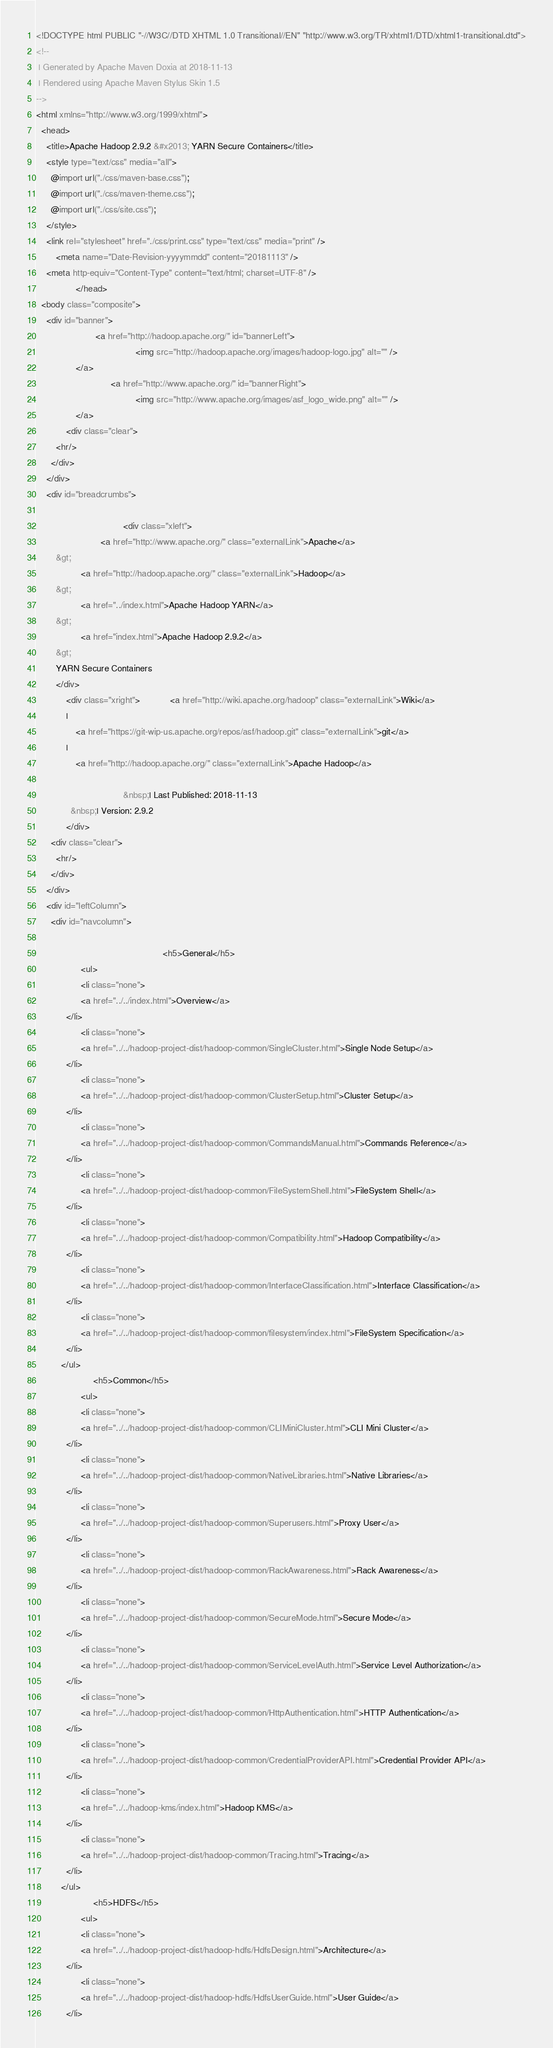Convert code to text. <code><loc_0><loc_0><loc_500><loc_500><_HTML_><!DOCTYPE html PUBLIC "-//W3C//DTD XHTML 1.0 Transitional//EN" "http://www.w3.org/TR/xhtml1/DTD/xhtml1-transitional.dtd">
<!--
 | Generated by Apache Maven Doxia at 2018-11-13
 | Rendered using Apache Maven Stylus Skin 1.5
-->
<html xmlns="http://www.w3.org/1999/xhtml">
  <head>
    <title>Apache Hadoop 2.9.2 &#x2013; YARN Secure Containers</title>
    <style type="text/css" media="all">
      @import url("./css/maven-base.css");
      @import url("./css/maven-theme.css");
      @import url("./css/site.css");
    </style>
    <link rel="stylesheet" href="./css/print.css" type="text/css" media="print" />
        <meta name="Date-Revision-yyyymmdd" content="20181113" />
    <meta http-equiv="Content-Type" content="text/html; charset=UTF-8" />
                </head>
  <body class="composite">
    <div id="banner">
                        <a href="http://hadoop.apache.org/" id="bannerLeft">
                                        <img src="http://hadoop.apache.org/images/hadoop-logo.jpg" alt="" />
                </a>
                              <a href="http://www.apache.org/" id="bannerRight">
                                        <img src="http://www.apache.org/images/asf_logo_wide.png" alt="" />
                </a>
            <div class="clear">
        <hr/>
      </div>
    </div>
    <div id="breadcrumbs">
            
                                   <div class="xleft">
                          <a href="http://www.apache.org/" class="externalLink">Apache</a>
        &gt;
                  <a href="http://hadoop.apache.org/" class="externalLink">Hadoop</a>
        &gt;
                  <a href="../index.html">Apache Hadoop YARN</a>
        &gt;
                  <a href="index.html">Apache Hadoop 2.9.2</a>
        &gt;
        YARN Secure Containers
        </div>
            <div class="xright">            <a href="http://wiki.apache.org/hadoop" class="externalLink">Wiki</a>
            |
                <a href="https://git-wip-us.apache.org/repos/asf/hadoop.git" class="externalLink">git</a>
            |
                <a href="http://hadoop.apache.org/" class="externalLink">Apache Hadoop</a>
              
                                   &nbsp;| Last Published: 2018-11-13
              &nbsp;| Version: 2.9.2
            </div>
      <div class="clear">
        <hr/>
      </div>
    </div>
    <div id="leftColumn">
      <div id="navcolumn">
             
                                                   <h5>General</h5>
                  <ul>
                  <li class="none">
                  <a href="../../index.html">Overview</a>
            </li>
                  <li class="none">
                  <a href="../../hadoop-project-dist/hadoop-common/SingleCluster.html">Single Node Setup</a>
            </li>
                  <li class="none">
                  <a href="../../hadoop-project-dist/hadoop-common/ClusterSetup.html">Cluster Setup</a>
            </li>
                  <li class="none">
                  <a href="../../hadoop-project-dist/hadoop-common/CommandsManual.html">Commands Reference</a>
            </li>
                  <li class="none">
                  <a href="../../hadoop-project-dist/hadoop-common/FileSystemShell.html">FileSystem Shell</a>
            </li>
                  <li class="none">
                  <a href="../../hadoop-project-dist/hadoop-common/Compatibility.html">Hadoop Compatibility</a>
            </li>
                  <li class="none">
                  <a href="../../hadoop-project-dist/hadoop-common/InterfaceClassification.html">Interface Classification</a>
            </li>
                  <li class="none">
                  <a href="../../hadoop-project-dist/hadoop-common/filesystem/index.html">FileSystem Specification</a>
            </li>
          </ul>
                       <h5>Common</h5>
                  <ul>
                  <li class="none">
                  <a href="../../hadoop-project-dist/hadoop-common/CLIMiniCluster.html">CLI Mini Cluster</a>
            </li>
                  <li class="none">
                  <a href="../../hadoop-project-dist/hadoop-common/NativeLibraries.html">Native Libraries</a>
            </li>
                  <li class="none">
                  <a href="../../hadoop-project-dist/hadoop-common/Superusers.html">Proxy User</a>
            </li>
                  <li class="none">
                  <a href="../../hadoop-project-dist/hadoop-common/RackAwareness.html">Rack Awareness</a>
            </li>
                  <li class="none">
                  <a href="../../hadoop-project-dist/hadoop-common/SecureMode.html">Secure Mode</a>
            </li>
                  <li class="none">
                  <a href="../../hadoop-project-dist/hadoop-common/ServiceLevelAuth.html">Service Level Authorization</a>
            </li>
                  <li class="none">
                  <a href="../../hadoop-project-dist/hadoop-common/HttpAuthentication.html">HTTP Authentication</a>
            </li>
                  <li class="none">
                  <a href="../../hadoop-project-dist/hadoop-common/CredentialProviderAPI.html">Credential Provider API</a>
            </li>
                  <li class="none">
                  <a href="../../hadoop-kms/index.html">Hadoop KMS</a>
            </li>
                  <li class="none">
                  <a href="../../hadoop-project-dist/hadoop-common/Tracing.html">Tracing</a>
            </li>
          </ul>
                       <h5>HDFS</h5>
                  <ul>
                  <li class="none">
                  <a href="../../hadoop-project-dist/hadoop-hdfs/HdfsDesign.html">Architecture</a>
            </li>
                  <li class="none">
                  <a href="../../hadoop-project-dist/hadoop-hdfs/HdfsUserGuide.html">User Guide</a>
            </li></code> 